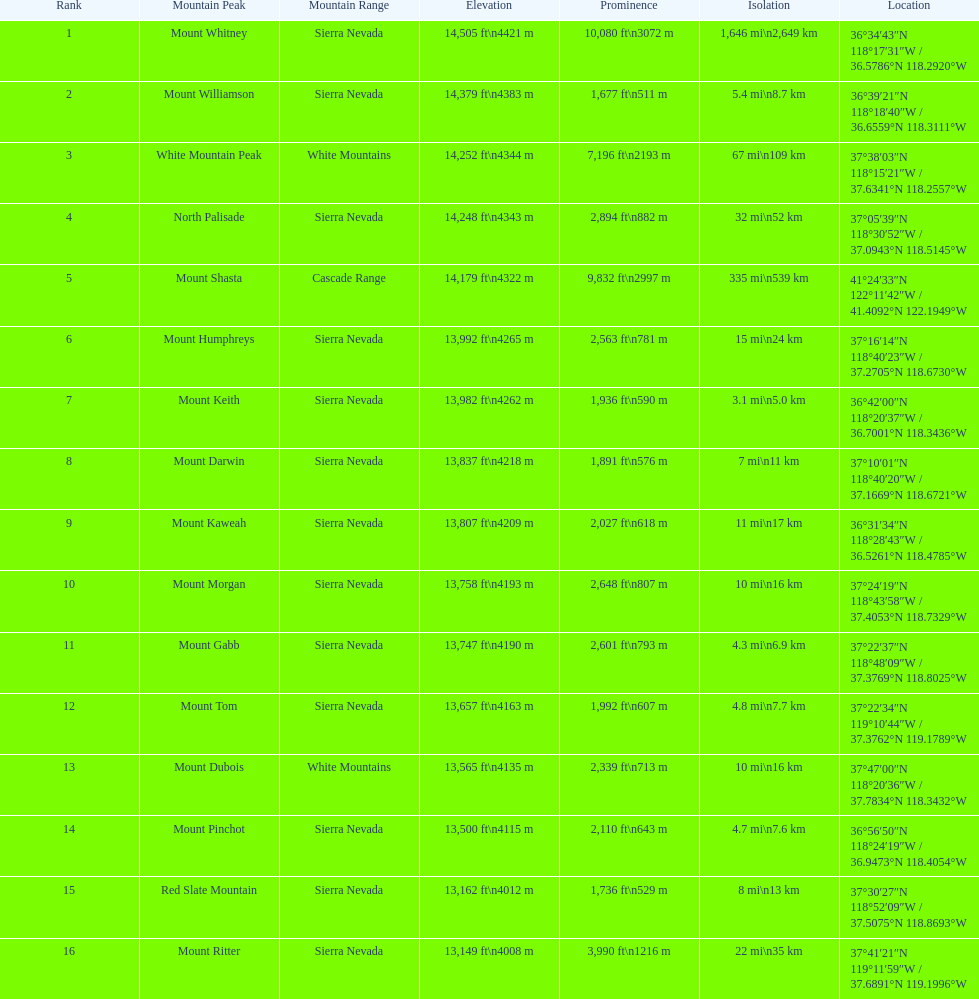Which mountain peak is the only mountain peak in the cascade range? Mount Shasta. 